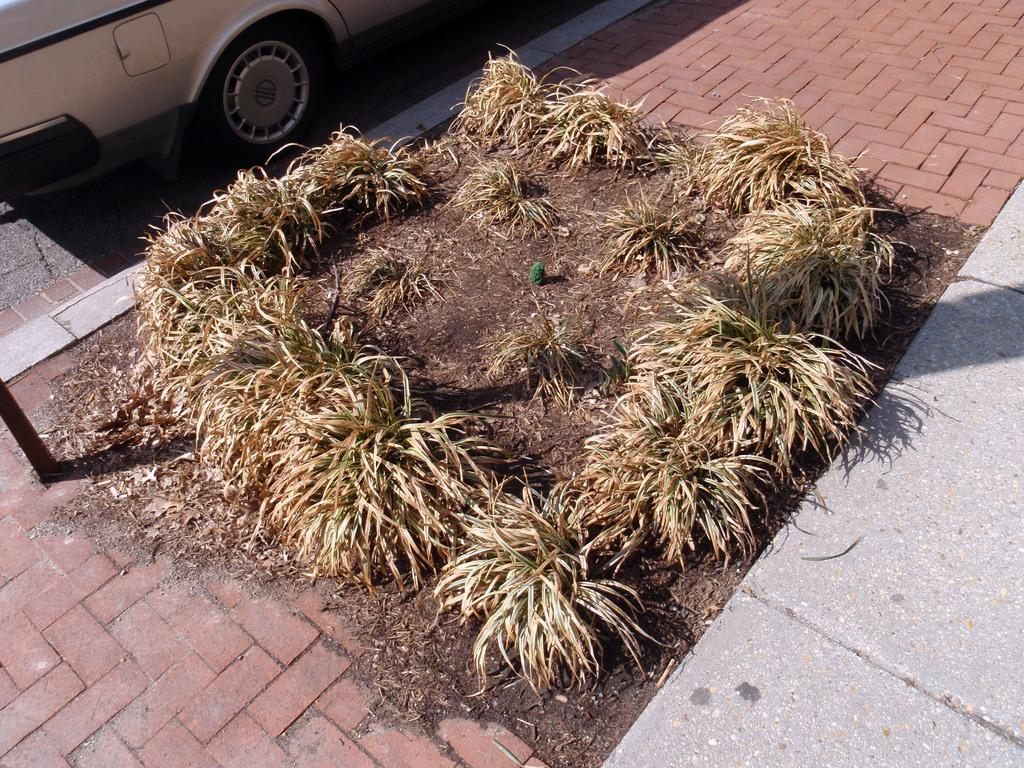What type of vegetation is present on the ground in the image? There are plants on the ground in the image. What structure can be seen in the image? There is a pole in the image. What type of vehicle is parked in the image? There is a car parked aside in the image. Can you tell me how many fans are visible in the image? There are no fans present in the image. What type of coastline can be seen in the image? There is no coastline visible in the image; it features plants, a pole, and a parked car. 